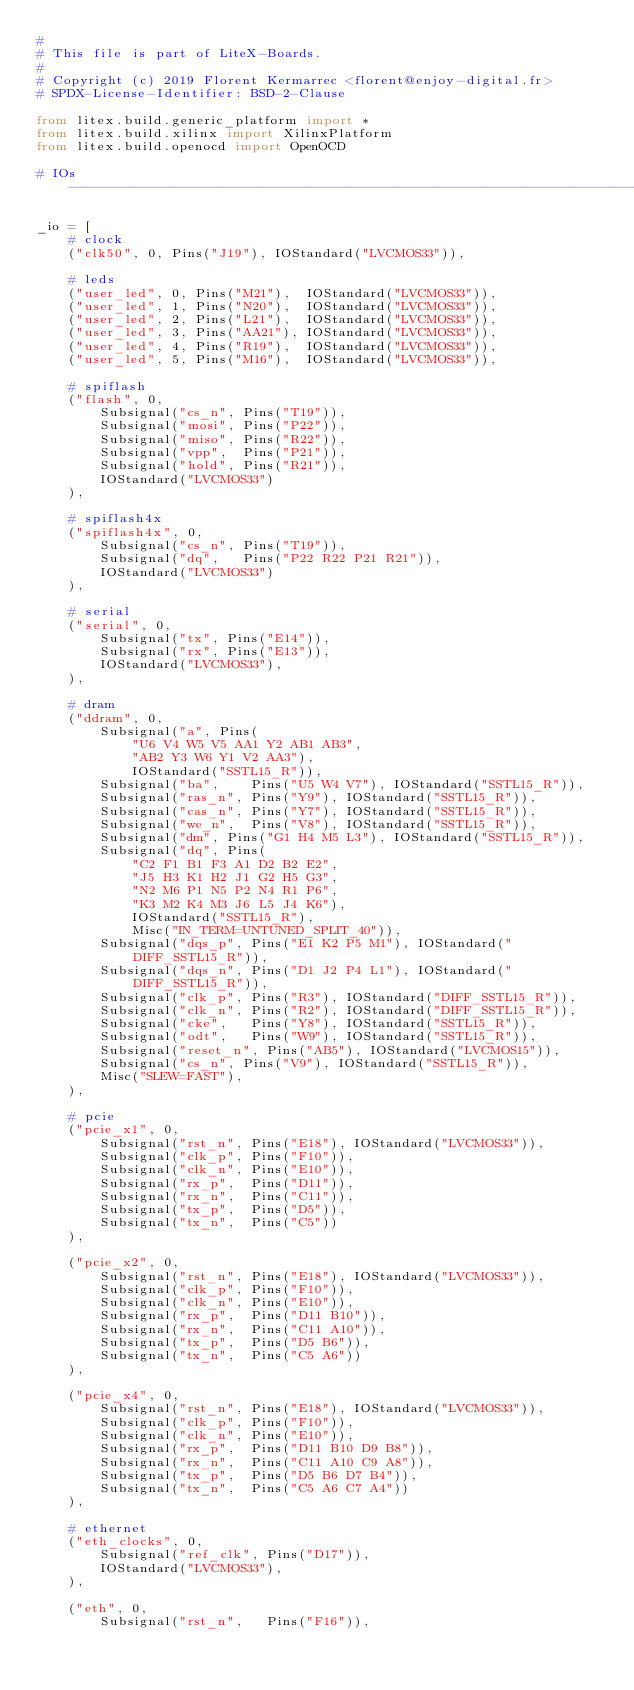Convert code to text. <code><loc_0><loc_0><loc_500><loc_500><_Python_>#
# This file is part of LiteX-Boards.
#
# Copyright (c) 2019 Florent Kermarrec <florent@enjoy-digital.fr>
# SPDX-License-Identifier: BSD-2-Clause

from litex.build.generic_platform import *
from litex.build.xilinx import XilinxPlatform
from litex.build.openocd import OpenOCD

# IOs ----------------------------------------------------------------------------------------------

_io = [
    # clock
    ("clk50", 0, Pins("J19"), IOStandard("LVCMOS33")),

    # leds
    ("user_led", 0, Pins("M21"),  IOStandard("LVCMOS33")),
    ("user_led", 1, Pins("N20"),  IOStandard("LVCMOS33")),
    ("user_led", 2, Pins("L21"),  IOStandard("LVCMOS33")),
    ("user_led", 3, Pins("AA21"), IOStandard("LVCMOS33")),
    ("user_led", 4, Pins("R19"),  IOStandard("LVCMOS33")),
    ("user_led", 5, Pins("M16"),  IOStandard("LVCMOS33")),

    # spiflash
    ("flash", 0,
        Subsignal("cs_n", Pins("T19")),
        Subsignal("mosi", Pins("P22")),
        Subsignal("miso", Pins("R22")),
        Subsignal("vpp",  Pins("P21")),
        Subsignal("hold", Pins("R21")),
        IOStandard("LVCMOS33")
    ),

    # spiflash4x
    ("spiflash4x", 0,
        Subsignal("cs_n", Pins("T19")),
        Subsignal("dq",   Pins("P22 R22 P21 R21")),
        IOStandard("LVCMOS33")
    ),

    # serial
    ("serial", 0,
        Subsignal("tx", Pins("E14")),
        Subsignal("rx", Pins("E13")),
        IOStandard("LVCMOS33"),
    ),

    # dram
    ("ddram", 0,
        Subsignal("a", Pins(
            "U6 V4 W5 V5 AA1 Y2 AB1 AB3",
            "AB2 Y3 W6 Y1 V2 AA3"),
            IOStandard("SSTL15_R")),
        Subsignal("ba",    Pins("U5 W4 V7"), IOStandard("SSTL15_R")),
        Subsignal("ras_n", Pins("Y9"), IOStandard("SSTL15_R")),
        Subsignal("cas_n", Pins("Y7"), IOStandard("SSTL15_R")),
        Subsignal("we_n",  Pins("V8"), IOStandard("SSTL15_R")),
        Subsignal("dm", Pins("G1 H4 M5 L3"), IOStandard("SSTL15_R")),
        Subsignal("dq", Pins(
            "C2 F1 B1 F3 A1 D2 B2 E2",
            "J5 H3 K1 H2 J1 G2 H5 G3",
            "N2 M6 P1 N5 P2 N4 R1 P6",
            "K3 M2 K4 M3 J6 L5 J4 K6"),
            IOStandard("SSTL15_R"),
            Misc("IN_TERM=UNTUNED_SPLIT_40")),
        Subsignal("dqs_p", Pins("E1 K2 P5 M1"), IOStandard("DIFF_SSTL15_R")),
        Subsignal("dqs_n", Pins("D1 J2 P4 L1"), IOStandard("DIFF_SSTL15_R")),
        Subsignal("clk_p", Pins("R3"), IOStandard("DIFF_SSTL15_R")),
        Subsignal("clk_n", Pins("R2"), IOStandard("DIFF_SSTL15_R")),
        Subsignal("cke",   Pins("Y8"), IOStandard("SSTL15_R")),
        Subsignal("odt",   Pins("W9"), IOStandard("SSTL15_R")),
        Subsignal("reset_n", Pins("AB5"), IOStandard("LVCMOS15")),
        Subsignal("cs_n", Pins("V9"), IOStandard("SSTL15_R")),
        Misc("SLEW=FAST"),
    ),

    # pcie
    ("pcie_x1", 0,
        Subsignal("rst_n", Pins("E18"), IOStandard("LVCMOS33")),
        Subsignal("clk_p", Pins("F10")),
        Subsignal("clk_n", Pins("E10")),
        Subsignal("rx_p",  Pins("D11")),
        Subsignal("rx_n",  Pins("C11")),
        Subsignal("tx_p",  Pins("D5")),
        Subsignal("tx_n",  Pins("C5"))
    ),

    ("pcie_x2", 0,
        Subsignal("rst_n", Pins("E18"), IOStandard("LVCMOS33")),
        Subsignal("clk_p", Pins("F10")),
        Subsignal("clk_n", Pins("E10")),
        Subsignal("rx_p",  Pins("D11 B10")),
        Subsignal("rx_n",  Pins("C11 A10")),
        Subsignal("tx_p",  Pins("D5 B6")),
        Subsignal("tx_n",  Pins("C5 A6"))
    ),

    ("pcie_x4", 0,
        Subsignal("rst_n", Pins("E18"), IOStandard("LVCMOS33")),
        Subsignal("clk_p", Pins("F10")),
        Subsignal("clk_n", Pins("E10")),
        Subsignal("rx_p",  Pins("D11 B10 D9 B8")),
        Subsignal("rx_n",  Pins("C11 A10 C9 A8")),
        Subsignal("tx_p",  Pins("D5 B6 D7 B4")),
        Subsignal("tx_n",  Pins("C5 A6 C7 A4"))
    ),

    # ethernet
    ("eth_clocks", 0,
        Subsignal("ref_clk", Pins("D17")),
        IOStandard("LVCMOS33"),
    ),

    ("eth", 0,
        Subsignal("rst_n",   Pins("F16")),</code> 